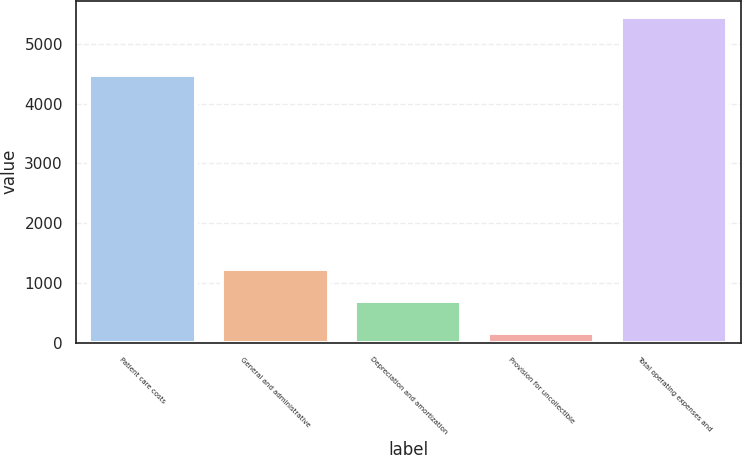Convert chart to OTSL. <chart><loc_0><loc_0><loc_500><loc_500><bar_chart><fcel>Patient care costs<fcel>General and administrative<fcel>Depreciation and amortization<fcel>Provision for uncollectible<fcel>Total operating expenses and<nl><fcel>4475<fcel>1226.8<fcel>698.9<fcel>171<fcel>5450<nl></chart> 